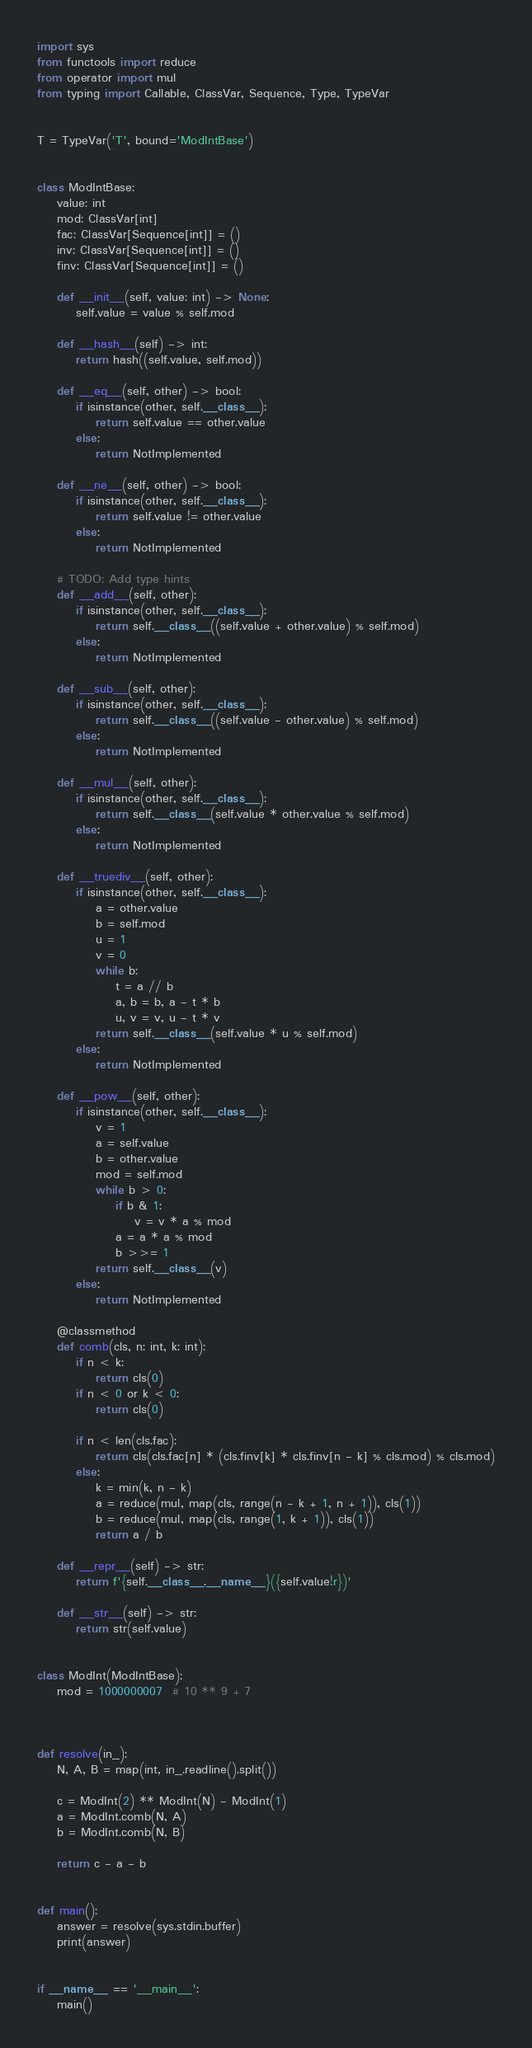<code> <loc_0><loc_0><loc_500><loc_500><_Python_>import sys
from functools import reduce
from operator import mul
from typing import Callable, ClassVar, Sequence, Type, TypeVar


T = TypeVar('T', bound='ModIntBase')


class ModIntBase:
    value: int
    mod: ClassVar[int]
    fac: ClassVar[Sequence[int]] = ()
    inv: ClassVar[Sequence[int]] = ()
    finv: ClassVar[Sequence[int]] = ()

    def __init__(self, value: int) -> None:
        self.value = value % self.mod

    def __hash__(self) -> int:
        return hash((self.value, self.mod))

    def __eq__(self, other) -> bool:
        if isinstance(other, self.__class__):
            return self.value == other.value
        else:
            return NotImplemented

    def __ne__(self, other) -> bool:
        if isinstance(other, self.__class__):
            return self.value != other.value
        else:
            return NotImplemented

    # TODO: Add type hints
    def __add__(self, other):
        if isinstance(other, self.__class__):
            return self.__class__((self.value + other.value) % self.mod)
        else:
            return NotImplemented

    def __sub__(self, other):
        if isinstance(other, self.__class__):
            return self.__class__((self.value - other.value) % self.mod)
        else:
            return NotImplemented

    def __mul__(self, other):
        if isinstance(other, self.__class__):
            return self.__class__(self.value * other.value % self.mod)
        else:
            return NotImplemented

    def __truediv__(self, other):
        if isinstance(other, self.__class__):
            a = other.value
            b = self.mod
            u = 1
            v = 0
            while b:
                t = a // b
                a, b = b, a - t * b
                u, v = v, u - t * v
            return self.__class__(self.value * u % self.mod)
        else:
            return NotImplemented

    def __pow__(self, other):
        if isinstance(other, self.__class__):
            v = 1
            a = self.value
            b = other.value
            mod = self.mod
            while b > 0:
                if b & 1:
                    v = v * a % mod
                a = a * a % mod
                b >>= 1
            return self.__class__(v)
        else:
            return NotImplemented

    @classmethod
    def comb(cls, n: int, k: int):
        if n < k:
            return cls(0)
        if n < 0 or k < 0:
            return cls(0)

        if n < len(cls.fac):
            return cls(cls.fac[n] * (cls.finv[k] * cls.finv[n - k] % cls.mod) % cls.mod)
        else:
            k = min(k, n - k)
            a = reduce(mul, map(cls, range(n - k + 1, n + 1)), cls(1))
            b = reduce(mul, map(cls, range(1, k + 1)), cls(1))
            return a / b

    def __repr__(self) -> str:
        return f'{self.__class__.__name__}({self.value!r})'

    def __str__(self) -> str:
        return str(self.value)


class ModInt(ModIntBase):
    mod = 1000000007  # 10 ** 9 + 7



def resolve(in_):
    N, A, B = map(int, in_.readline().split())
    
    c = ModInt(2) ** ModInt(N) - ModInt(1)
    a = ModInt.comb(N, A)
    b = ModInt.comb(N, B)
    
    return c - a - b


def main():
    answer = resolve(sys.stdin.buffer)
    print(answer)


if __name__ == '__main__':
    main()
</code> 